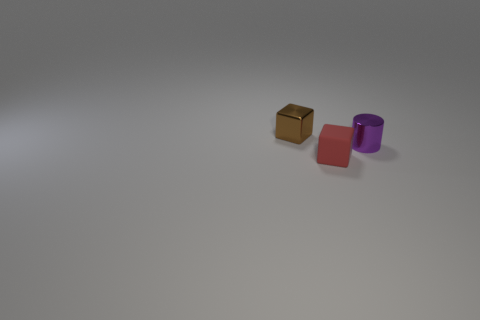Add 1 brown things. How many objects exist? 4 Subtract all cubes. How many objects are left? 1 Add 1 small cubes. How many small cubes are left? 3 Add 1 red matte blocks. How many red matte blocks exist? 2 Subtract 0 cyan blocks. How many objects are left? 3 Subtract all tiny blue shiny things. Subtract all red matte blocks. How many objects are left? 2 